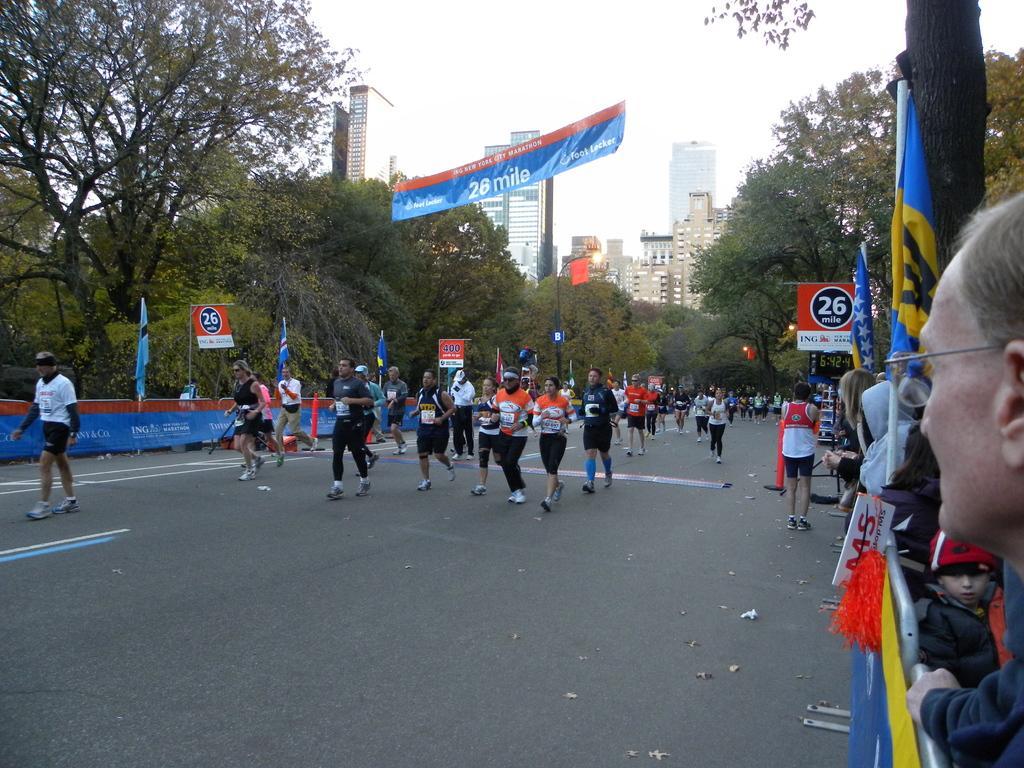Could you give a brief overview of what you see in this image? In this image we can see a group of persons walking on a road. Behind the persons we can see barriers, banners, boards, flags and trees. On the boards and banners, we can see the text. On the right side, we can see the person's, flags, banners and barriers. In the background, we can see a group of trees and buildings. At the top we can see the sky and a banner. On the banner we can see the text. 